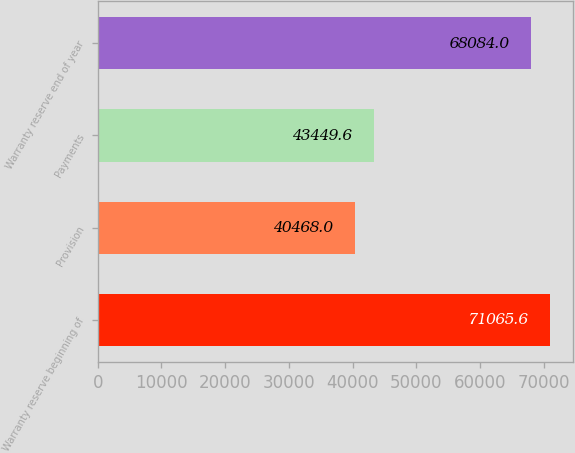Convert chart to OTSL. <chart><loc_0><loc_0><loc_500><loc_500><bar_chart><fcel>Warranty reserve beginning of<fcel>Provision<fcel>Payments<fcel>Warranty reserve end of year<nl><fcel>71065.6<fcel>40468<fcel>43449.6<fcel>68084<nl></chart> 